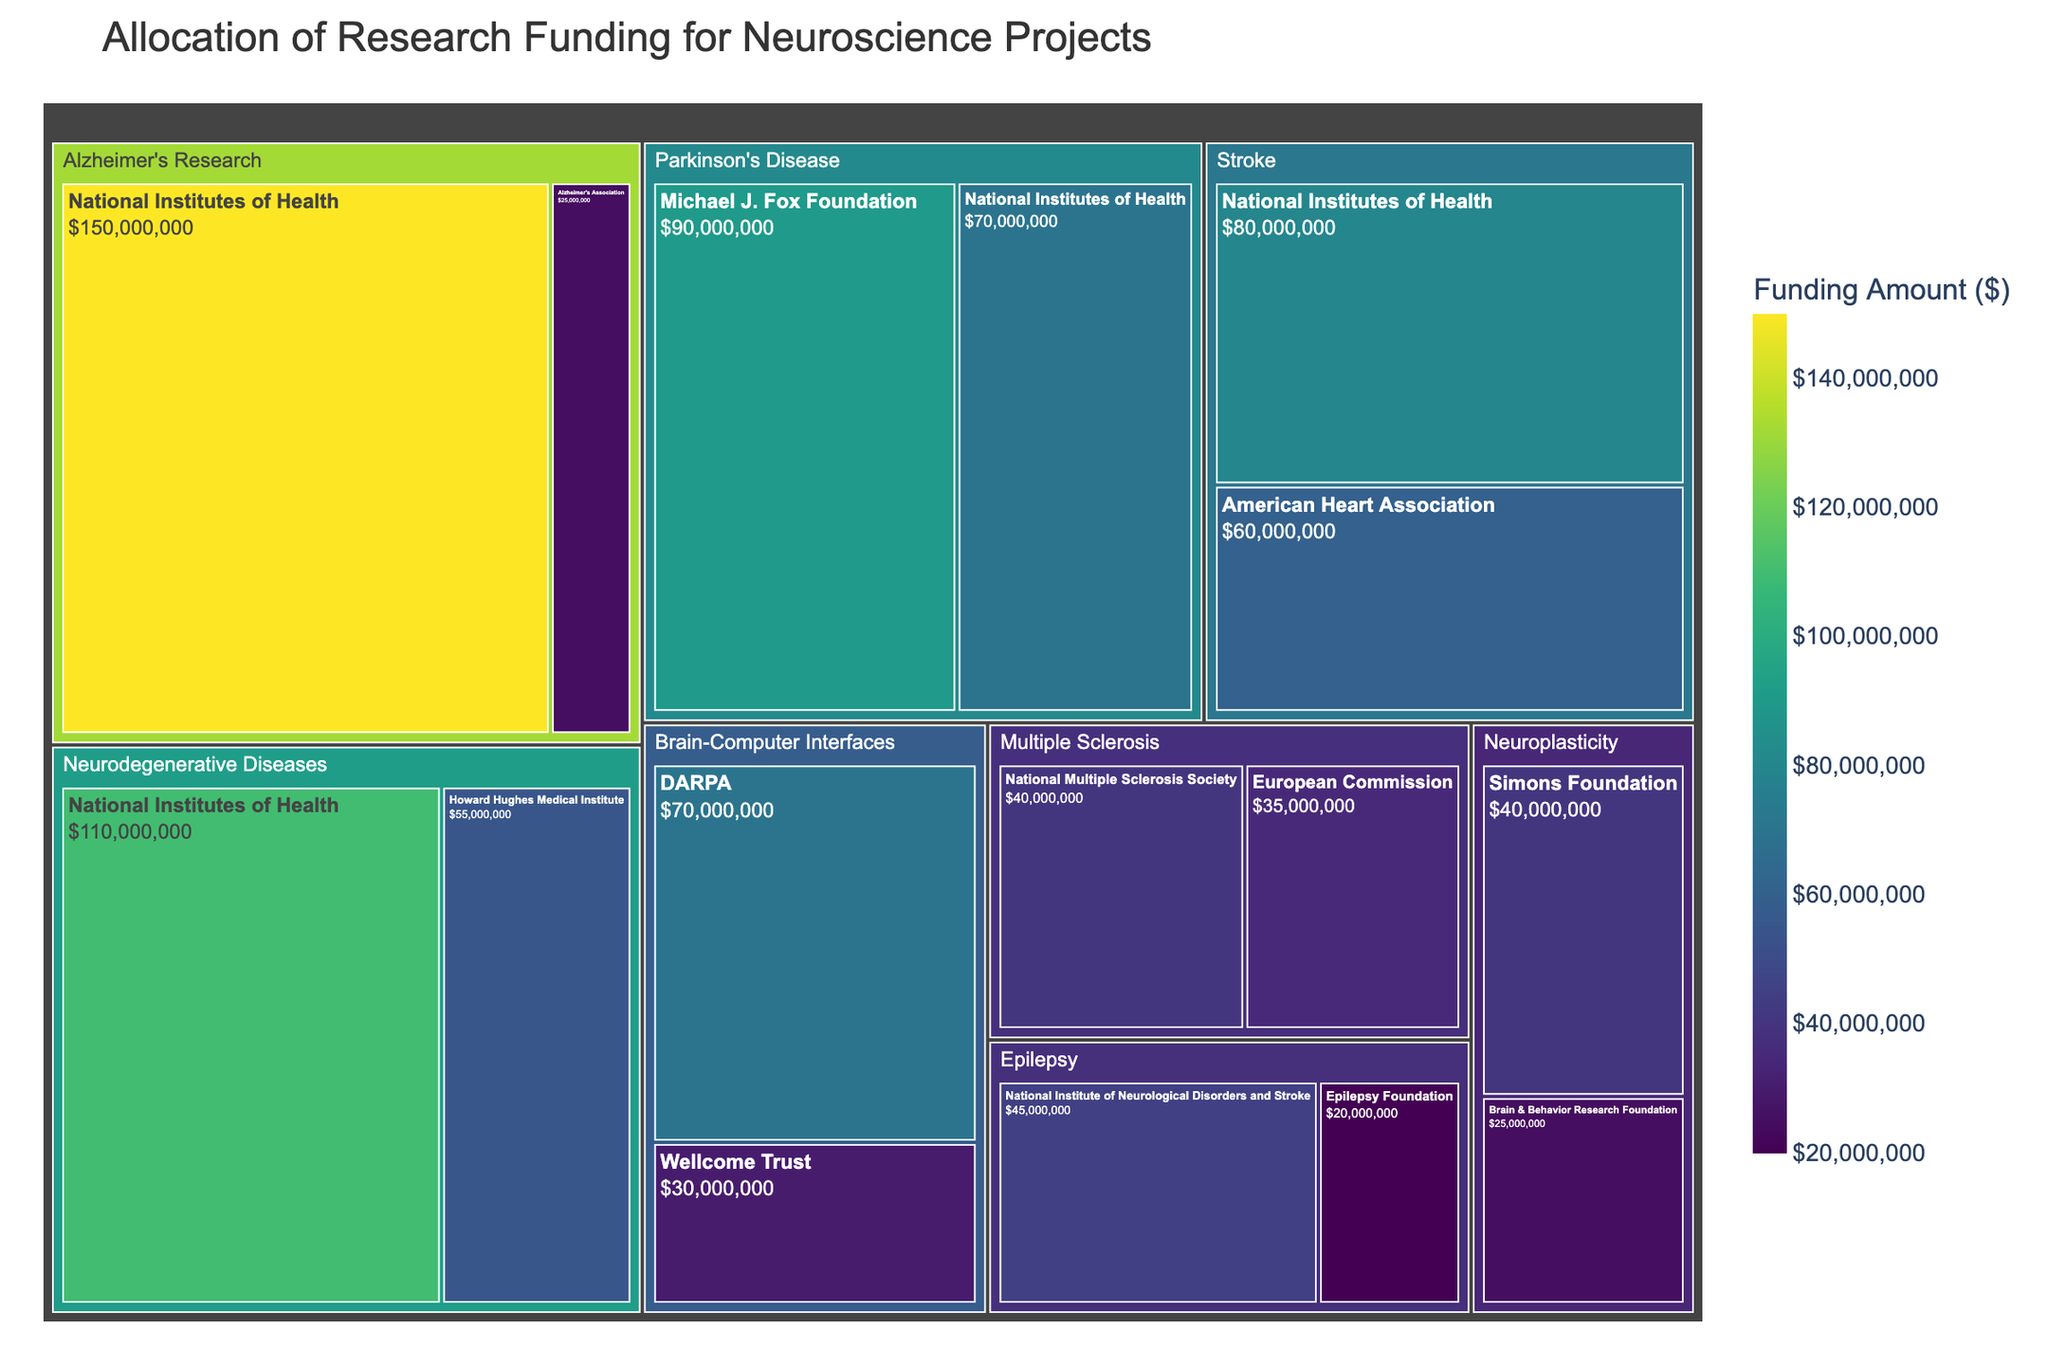What's the title of the treemap? The title of the treemap is clearly stated at the top of the figure.
Answer: Allocation of Research Funding for Neuroscience Projects Which area of study received the highest total funding? By examining which large rectangular area in the treemap contains the largest value, we can identify the area with the highest total funding.
Answer: Alzheimer's Research What is the total funding amount for Parkinson's Disease? We need to sum the funding amounts for Parkinson's Disease across all funding sources: Michael J. Fox Foundation ($90,000,000) and National Institutes of Health ($70,000,000). The total is $90,000,000 + $70,000,000.
Answer: $160,000,000 How does the funding amount for Multiple Sclerosis from the National Multiple Sclerosis Society compare to the amount from the European Commission? Compare the values for Multiple Sclerosis from the two sources: $40,000,000 from the National Multiple Sclerosis Society and $35,000,000 from the European Commission to determine which is higher.
Answer: National Multiple Sclerosis Society has $5,000,000 more What is the smallest funding amount listed, and which area and source does it belong to? Identify the smallest rectangle label on the treemap to find the smallest funding amount and its corresponding area and funding source.
Answer: Epilepsy from Epilepsy Foundation with $20,000,000 Which funding source contributes the most to Neurodegenerative Diseases? Look within the Neurodegenerative Diseases area and identify the funding source with the highest contribution: National Institutes of Health ($110,000,000) compared to Howard Hughes Medical Institute ($55,000,000).
Answer: National Institutes of Health Compare the total funding for Brain-Computer Interfaces to the total funding for Neuroplasticity. Calculate the total funding for Brain-Computer Interfaces: $70,000,000 (DARPA) + $30,000,000 (Wellcome Trust) = $100,000,000, and for Neuroplasticity: $40,000,000 (Simons Foundation) + $25,000,000 (Brain & Behavior Research Foundation) = $65,000,000. Then compare the two totals.
Answer: Brain-Computer Interfaces has $35,000,000 more Which funding source contributed the highest single amount to any area? Scan the treemap for the largest individual donation amount, which is indicated by the largest single rectangle.
Answer: National Institutes of Health for Alzheimer's Research with $150,000,000 What is the total funding amount for areas of study related to neurodegenerative diseases (Alzheimer's Research, Parkinson's Disease, Neurodegenerative Diseases)? Sum the total funding for Alzheimer's Research ($150,000,000 + $25,000,000), Parkinson's Disease ($90,000,000 + $70,000,000), and Neurodegenerative Diseases ($110,000,000 + $55,000,000).
Answer: $500,000,000 